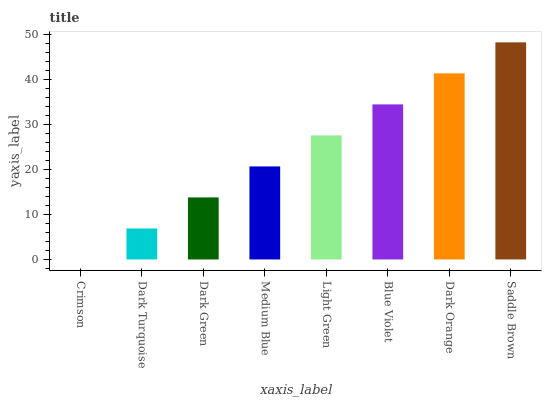Is Crimson the minimum?
Answer yes or no. Yes. Is Saddle Brown the maximum?
Answer yes or no. Yes. Is Dark Turquoise the minimum?
Answer yes or no. No. Is Dark Turquoise the maximum?
Answer yes or no. No. Is Dark Turquoise greater than Crimson?
Answer yes or no. Yes. Is Crimson less than Dark Turquoise?
Answer yes or no. Yes. Is Crimson greater than Dark Turquoise?
Answer yes or no. No. Is Dark Turquoise less than Crimson?
Answer yes or no. No. Is Light Green the high median?
Answer yes or no. Yes. Is Medium Blue the low median?
Answer yes or no. Yes. Is Blue Violet the high median?
Answer yes or no. No. Is Blue Violet the low median?
Answer yes or no. No. 